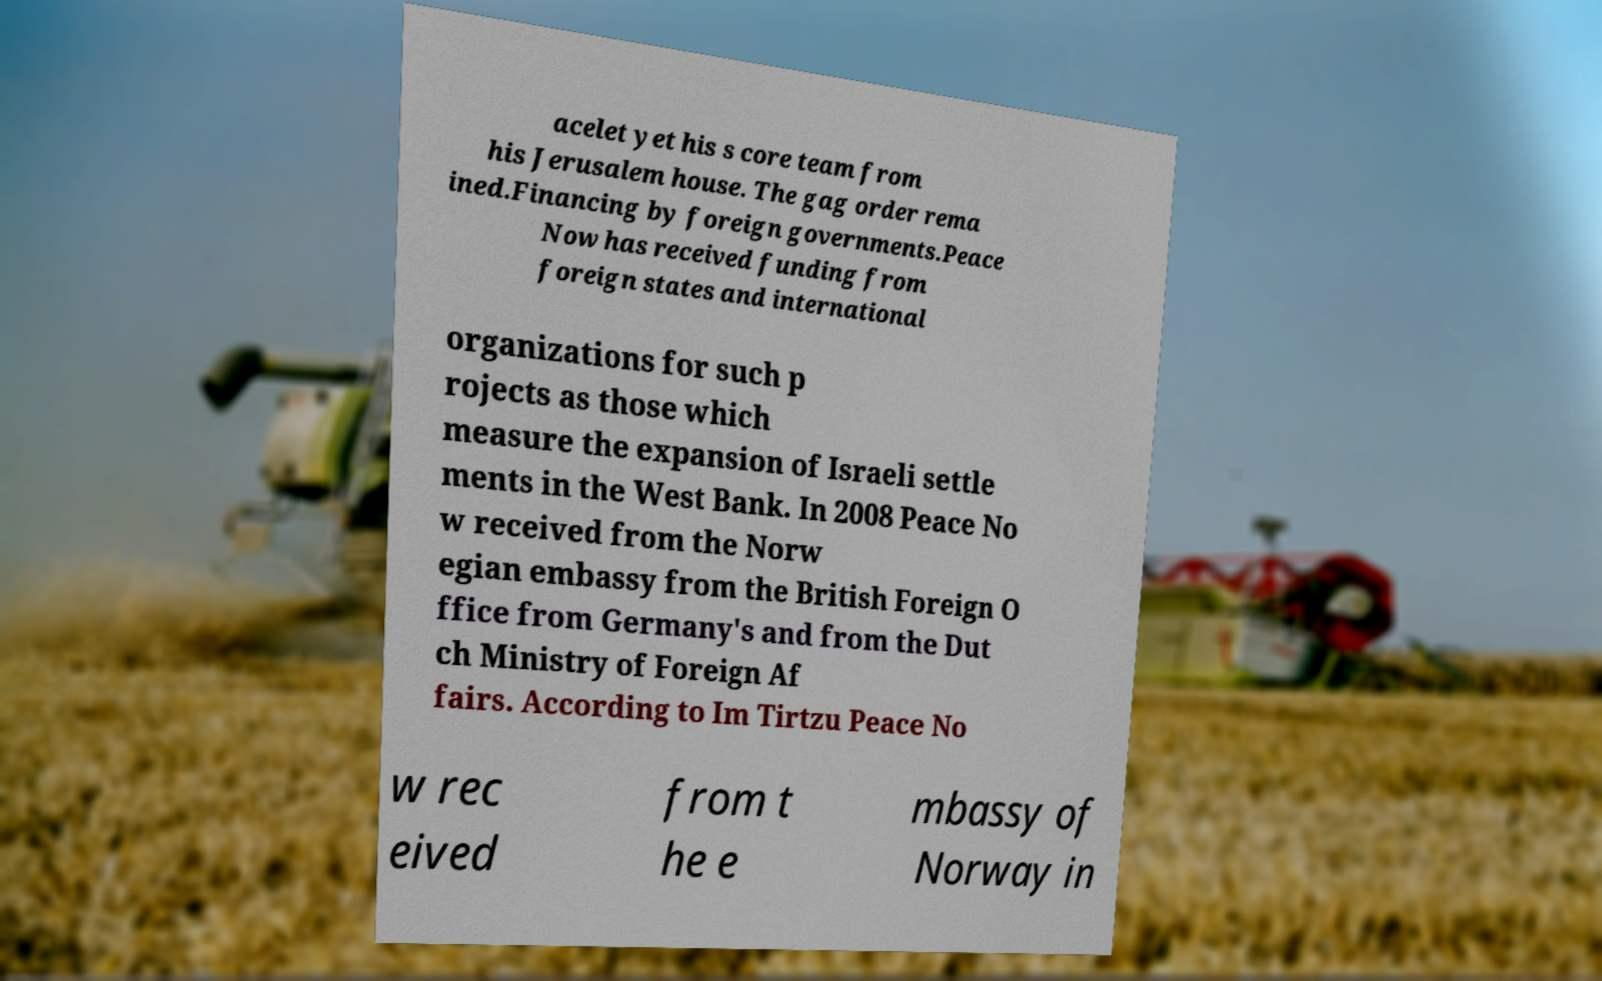I need the written content from this picture converted into text. Can you do that? acelet yet his s core team from his Jerusalem house. The gag order rema ined.Financing by foreign governments.Peace Now has received funding from foreign states and international organizations for such p rojects as those which measure the expansion of Israeli settle ments in the West Bank. In 2008 Peace No w received from the Norw egian embassy from the British Foreign O ffice from Germany's and from the Dut ch Ministry of Foreign Af fairs. According to Im Tirtzu Peace No w rec eived from t he e mbassy of Norway in 